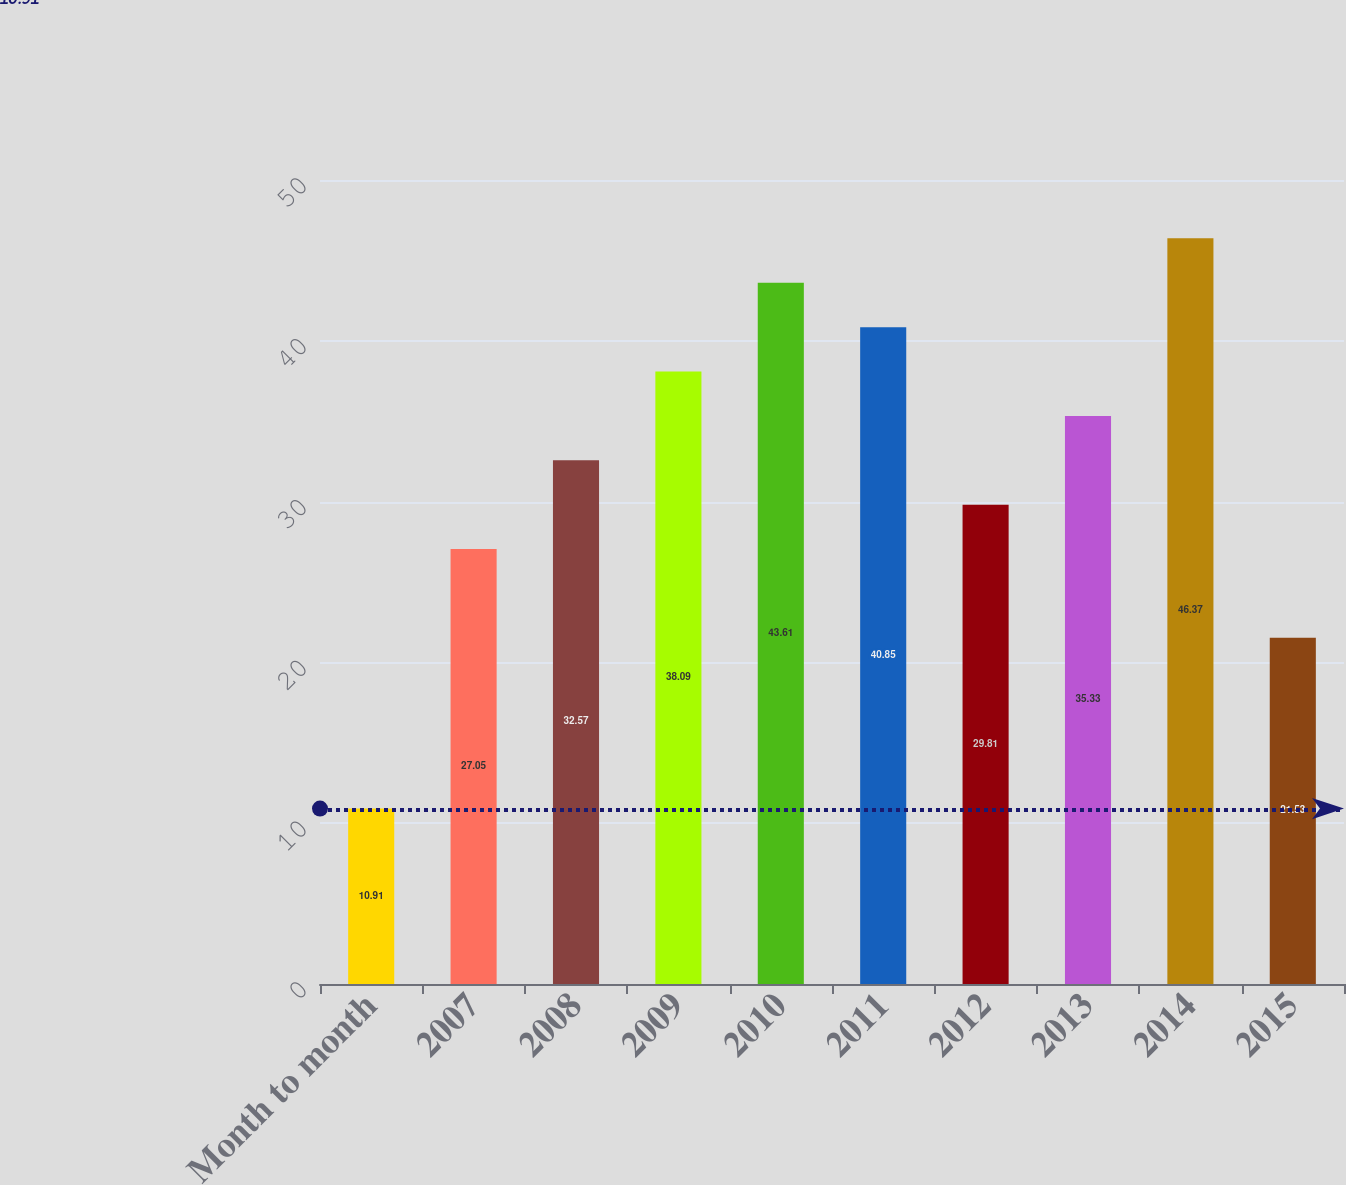<chart> <loc_0><loc_0><loc_500><loc_500><bar_chart><fcel>Month to month<fcel>2007<fcel>2008<fcel>2009<fcel>2010<fcel>2011<fcel>2012<fcel>2013<fcel>2014<fcel>2015<nl><fcel>10.91<fcel>27.05<fcel>32.57<fcel>38.09<fcel>43.61<fcel>40.85<fcel>29.81<fcel>35.33<fcel>46.37<fcel>21.53<nl></chart> 